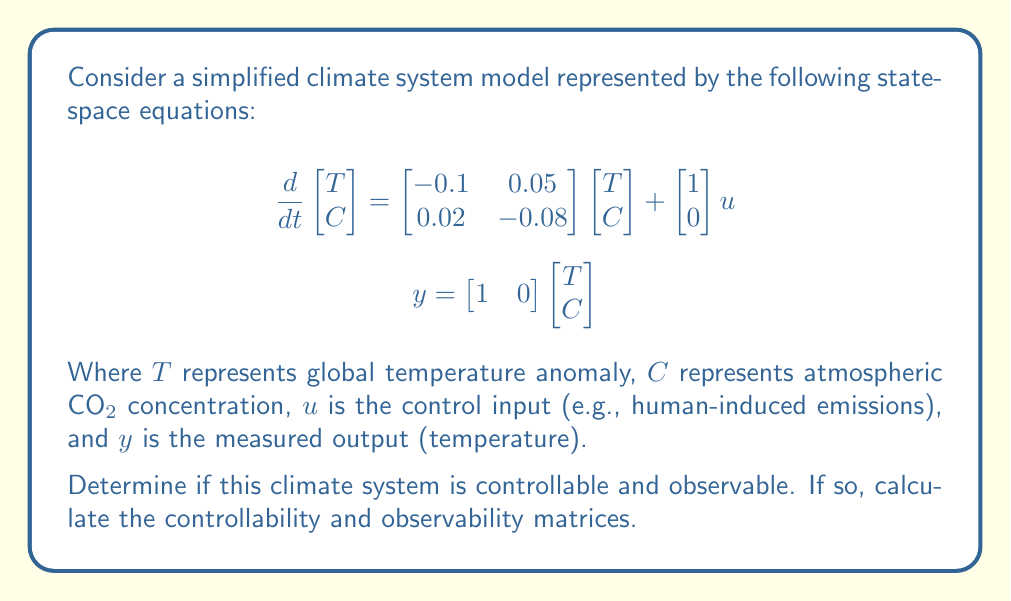Help me with this question. To determine if the system is controllable and observable, we need to check the rank of the controllability and observability matrices.

1. Controllability:
The controllability matrix is given by $\mathcal{C} = [B \quad AB]$, where $A$ is the state matrix and $B$ is the input matrix.

$$A = \begin{bmatrix} -0.1 & 0.05 \\ 0.02 & -0.08 \end{bmatrix}, \quad B = \begin{bmatrix} 1 \\ 0 \end{bmatrix}$$

First, calculate $AB$:

$$AB = \begin{bmatrix} -0.1 & 0.05 \\ 0.02 & -0.08 \end{bmatrix}\begin{bmatrix} 1 \\ 0 \end{bmatrix} = \begin{bmatrix} -0.1 \\ 0.02 \end{bmatrix}$$

Now, form the controllability matrix:

$$\mathcal{C} = [B \quad AB] = \begin{bmatrix} 1 & -0.1 \\ 0 & 0.02 \end{bmatrix}$$

The rank of $\mathcal{C}$ is 2, which is equal to the number of states. Therefore, the system is controllable.

2. Observability:
The observability matrix is given by $\mathcal{O} = \begin{bmatrix} C \\ CA \end{bmatrix}$, where $C$ is the output matrix.

$$C = \begin{bmatrix} 1 & 0 \end{bmatrix}$$

Calculate $CA$:

$$CA = \begin{bmatrix} 1 & 0 \end{bmatrix}\begin{bmatrix} -0.1 & 0.05 \\ 0.02 & -0.08 \end{bmatrix} = \begin{bmatrix} -0.1 & 0.05 \end{bmatrix}$$

Now, form the observability matrix:

$$\mathcal{O} = \begin{bmatrix} C \\ CA \end{bmatrix} = \begin{bmatrix} 1 & 0 \\ -0.1 & 0.05 \end{bmatrix}$$

The rank of $\mathcal{O}$ is 2, which is equal to the number of states. Therefore, the system is observable.
Answer: The climate system is both controllable and observable.

Controllability matrix: $$\mathcal{C} = \begin{bmatrix} 1 & -0.1 \\ 0 & 0.02 \end{bmatrix}$$

Observability matrix: $$\mathcal{O} = \begin{bmatrix} 1 & 0 \\ -0.1 & 0.05 \end{bmatrix}$$ 